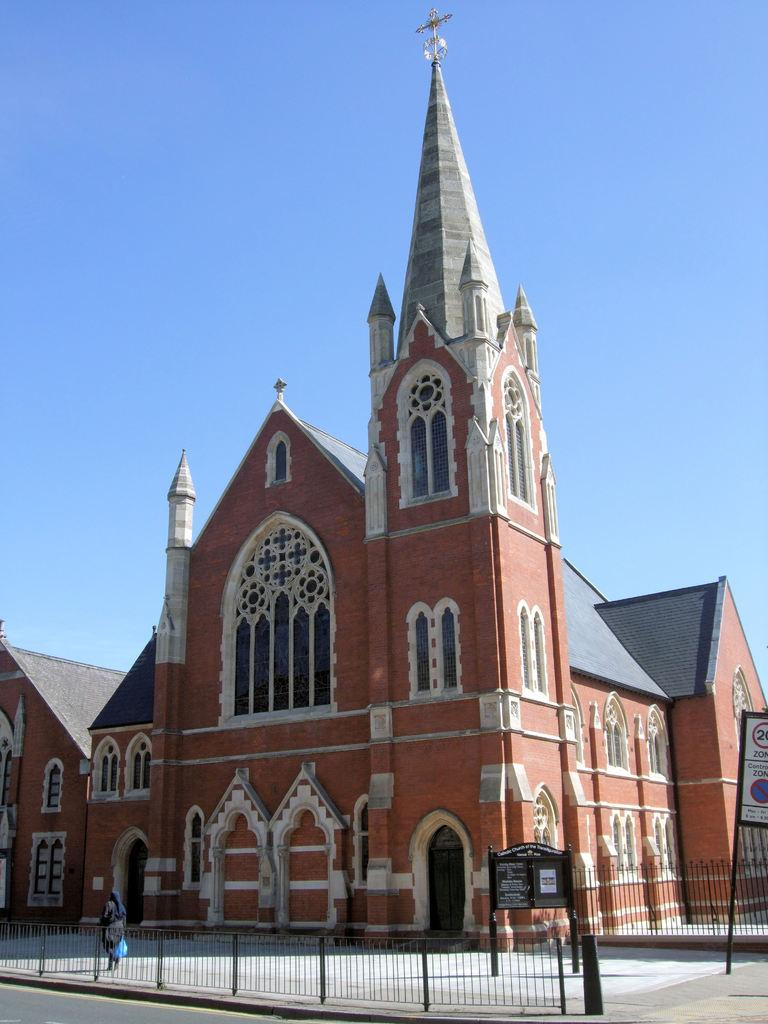What type of structure is visible in the image? There is a building in the image. What is located near the building? There is a fence in the image. Can you describe the person in the image? There is a person in the image. What else can be seen in the image besides the building and fence? There are boards in the image. What is at the bottom of the image? There is a road at the bottom of the image. What is visible at the top of the image? There is sky visible at the top of the image. How many times does the person in the image sneeze? There is no indication of the person sneezing in the image. What stage of development is the town in the image? There is no town present in the image, only a building, fence, boards, road, and sky. 